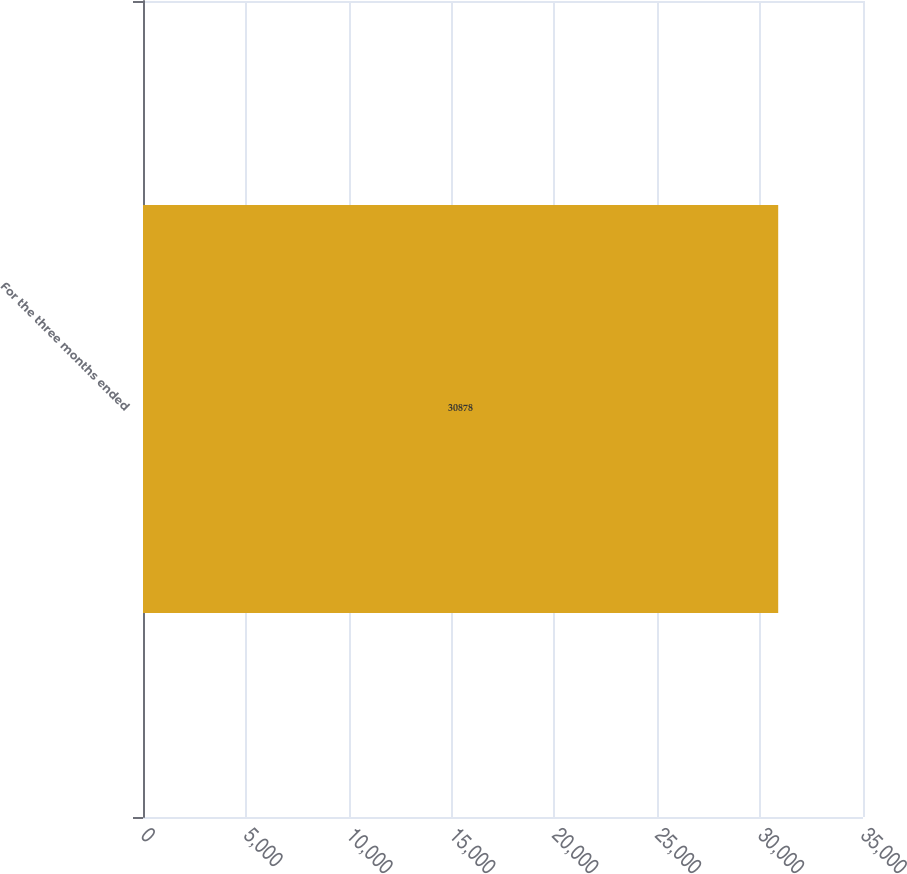Convert chart to OTSL. <chart><loc_0><loc_0><loc_500><loc_500><bar_chart><fcel>For the three months ended<nl><fcel>30878<nl></chart> 